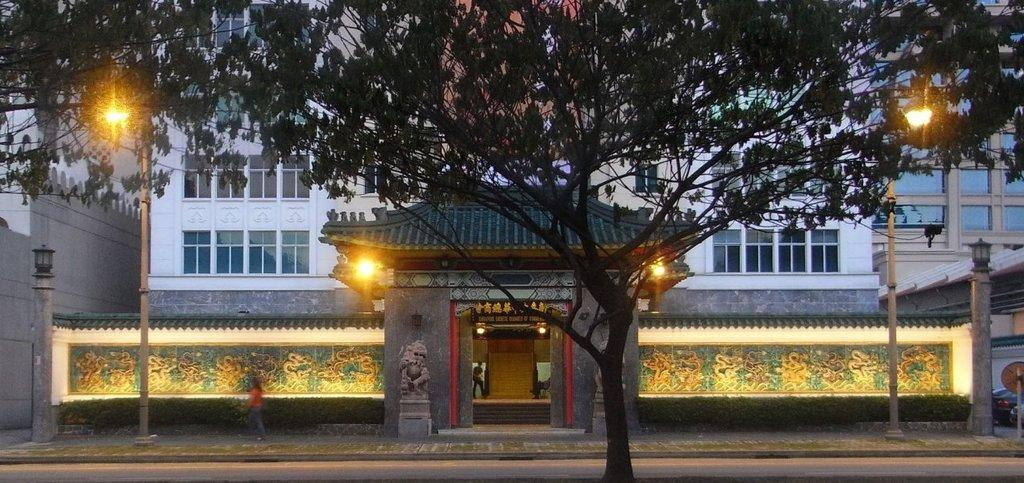What type of natural element can be seen in the image? There is a tree in the image. Who or what is present in the image? There are people in the image. What type of architecture is visible in the image? Ancient architecture is visible in the image. What can be used for illumination in the image? Lights are present in the image. What are the vertical structures in the image used for? Poles are visible in the image. What type of decorative elements can be seen on the walls in the image? Carvings on the walls are observable in the image. What type of structures can be seen in the background of the image? There are buildings in the background of the image. What day of the week is depicted in the image? The image does not depict a specific day of the week; it shows a scene with people, ancient architecture, and other elements. How does the image make you feel? The image itself does not evoke a specific feeling, as it is an inanimate object. The viewer's emotions may vary based on their personal experiences and preferences. 